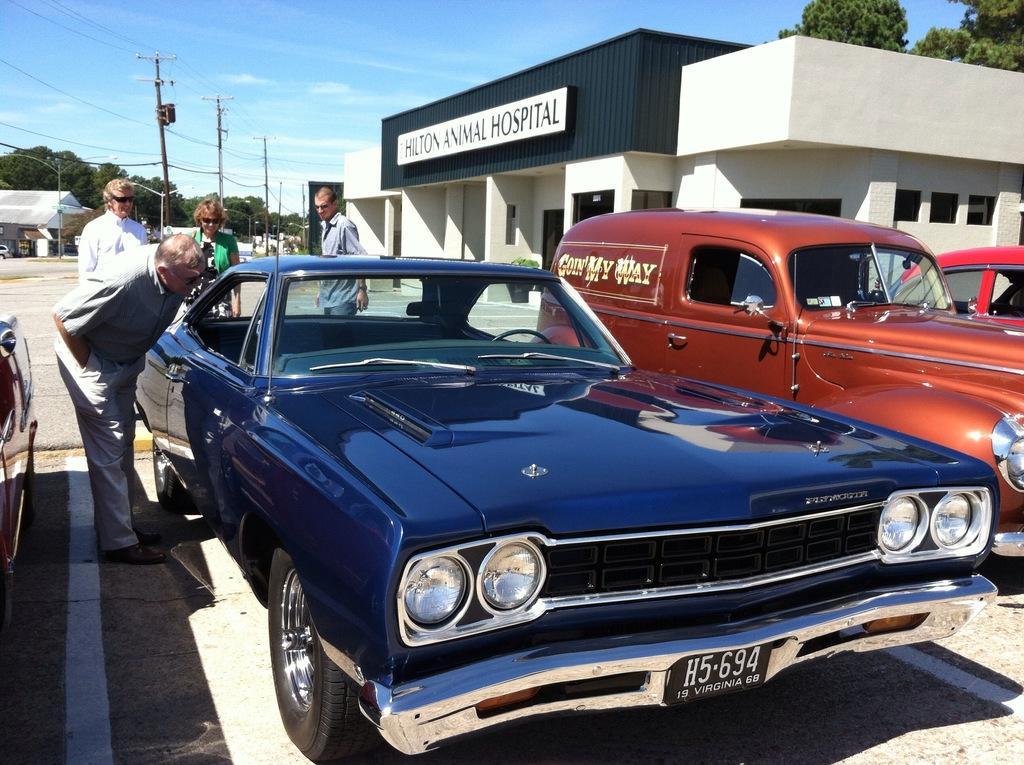How would you summarize this image in a sentence or two? In the image in the center we can see few vehicles and few people were standing. In the background we can see the sky,clouds,trees,poles,wires,buildings,banners and few other objects. 